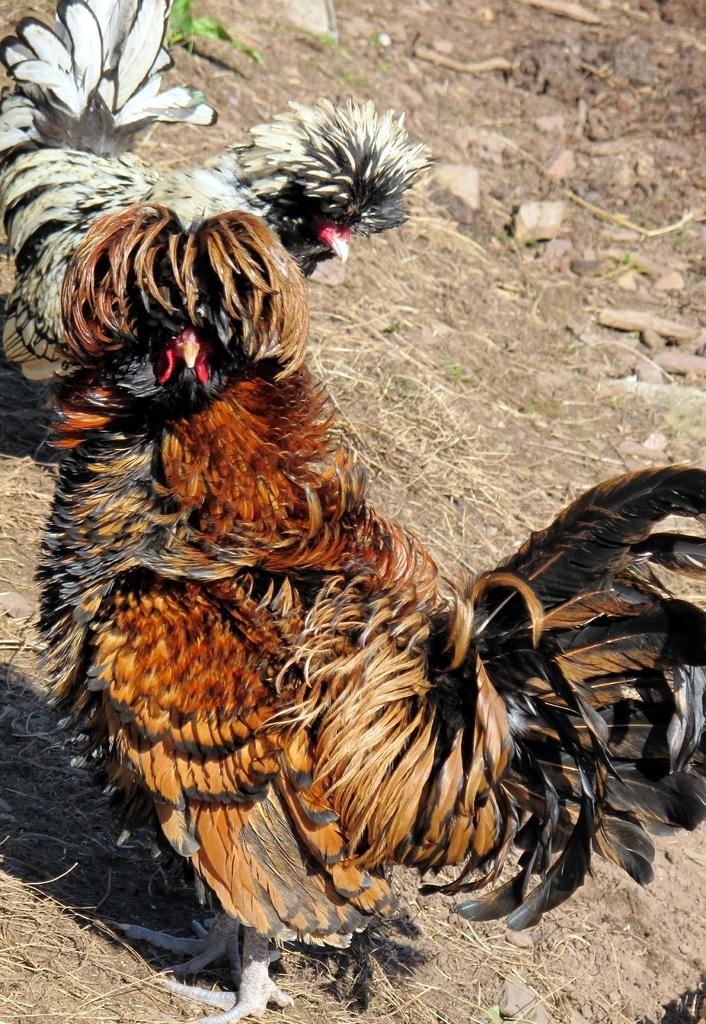What animals are present in the image? There are two hens in the image. Can you describe the position or location of the hens? The hens are on a surface in the image. What type of locket is the hen wearing in the image? There is no locket present in the image; the hens are not wearing any accessories. 